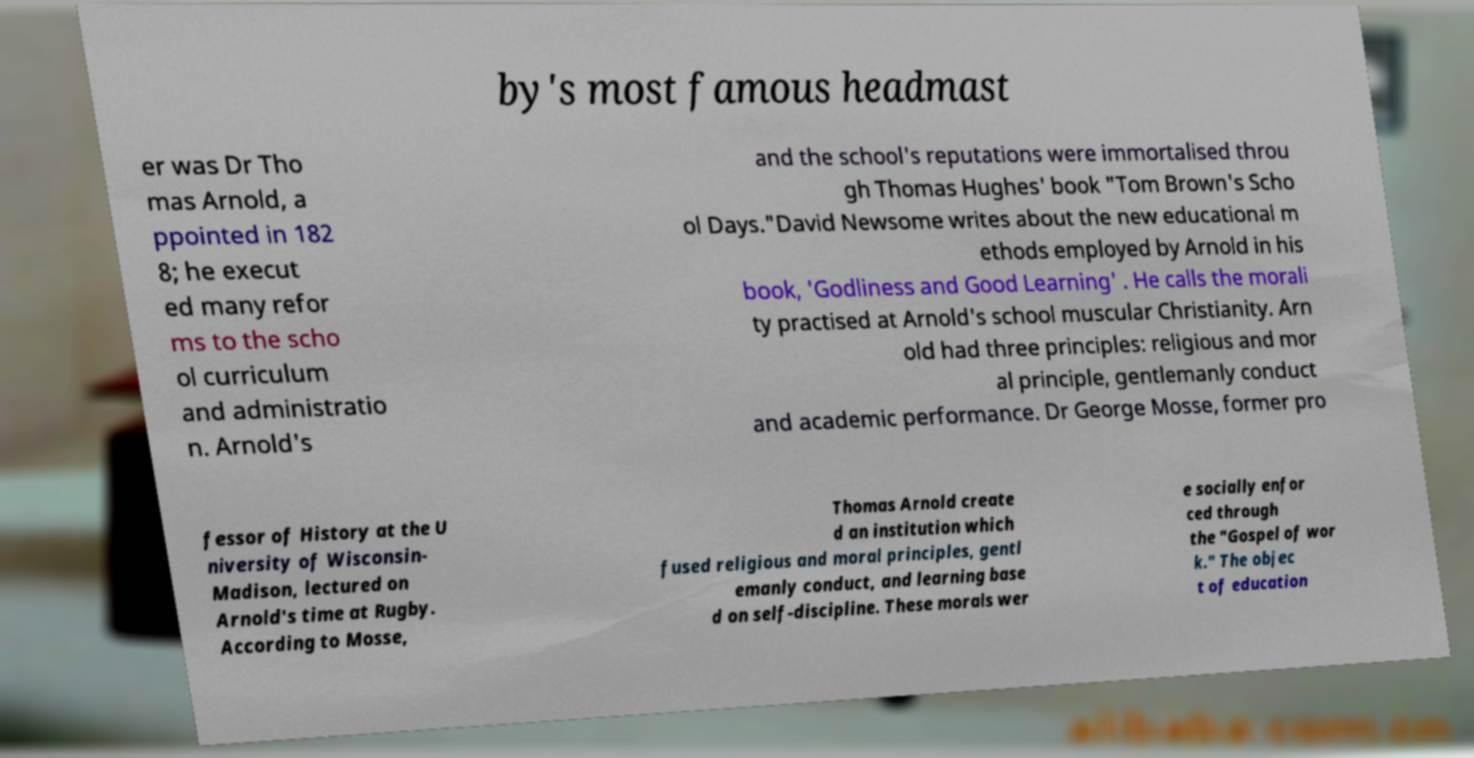Please identify and transcribe the text found in this image. by's most famous headmast er was Dr Tho mas Arnold, a ppointed in 182 8; he execut ed many refor ms to the scho ol curriculum and administratio n. Arnold's and the school's reputations were immortalised throu gh Thomas Hughes' book "Tom Brown's Scho ol Days."David Newsome writes about the new educational m ethods employed by Arnold in his book, 'Godliness and Good Learning' . He calls the morali ty practised at Arnold's school muscular Christianity. Arn old had three principles: religious and mor al principle, gentlemanly conduct and academic performance. Dr George Mosse, former pro fessor of History at the U niversity of Wisconsin- Madison, lectured on Arnold's time at Rugby. According to Mosse, Thomas Arnold create d an institution which fused religious and moral principles, gentl emanly conduct, and learning base d on self-discipline. These morals wer e socially enfor ced through the "Gospel of wor k." The objec t of education 